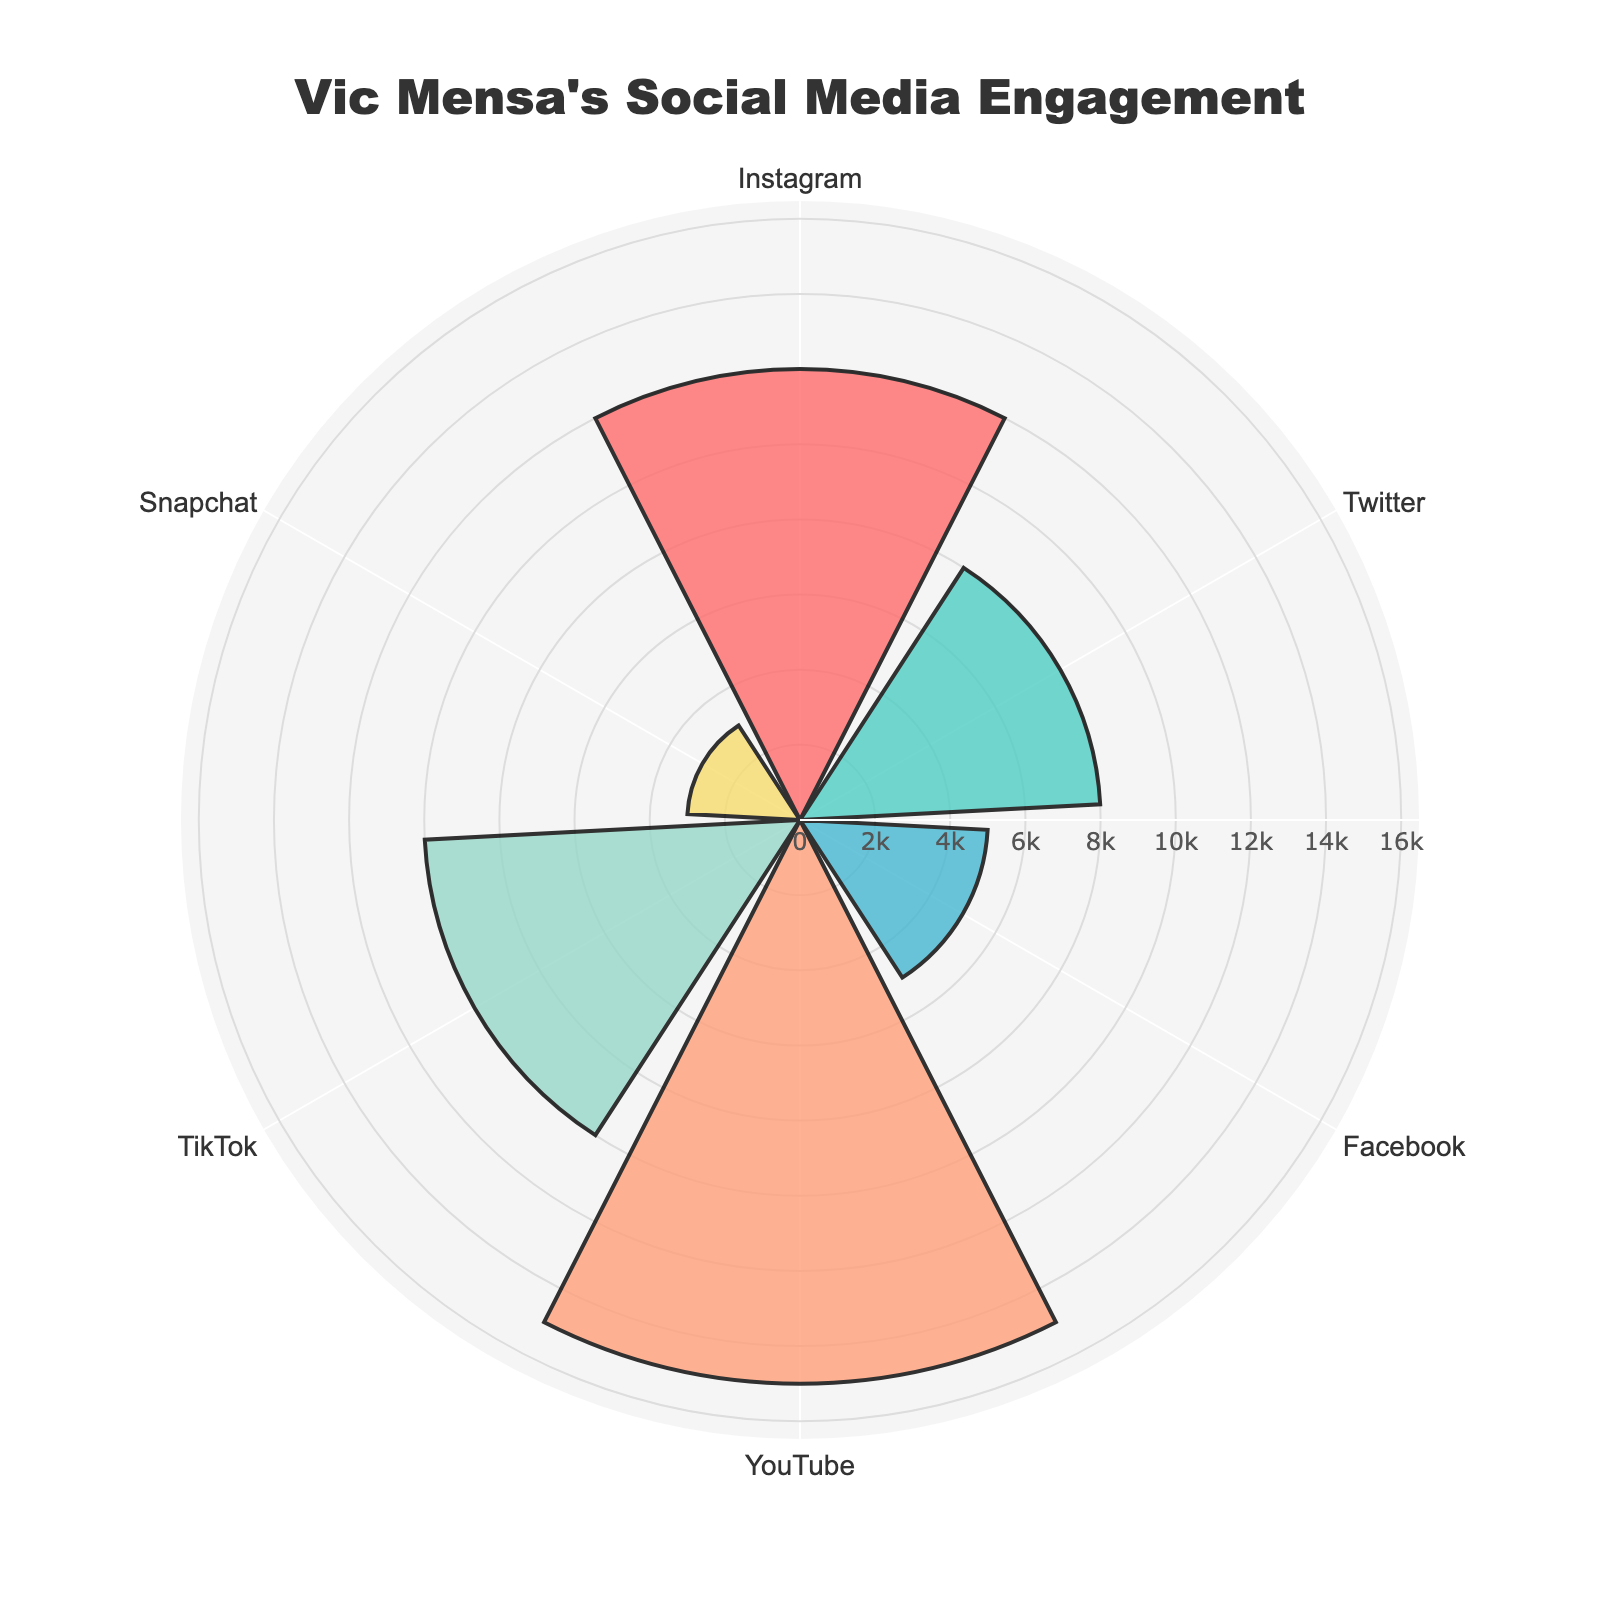Which platform has the highest social media engagement on Vic Mensa's posts? By looking at the chart, we can see the length of the bars representing engagement across different platforms. The longest bar corresponds to YouTube.
Answer: YouTube What are the two platforms with the lowest social media engagement on Vic Mensa's posts? Observing the chart, the shortest bars indicate the platforms with the lowest engagement. These platforms are Snapchat and Facebook.
Answer: Snapchat and Facebook What is the total social media engagement of Instagram and TikTok combined? To find the total engagement, sum the engagements of Instagram and TikTok, which are 12000 and 10000 respectively. Therefore, the total is 12000 + 10000.
Answer: 22000 How does Facebook's engagement compare to Snapchat's engagement? By comparing the bars for Facebook and Snapchat, we can see that Facebook's bar is longer than Snapchat's. This indicates that Facebook has higher engagement than Snapchat.
Answer: Facebook has higher engagement What's the radial range of the chart? The radial range can be observed from the polar chart's scale, which shows the range from 0 to the maximum engagement value extended by 10%. The maximum value is 15000, thus the range is approximately 0 to 16500.
Answer: 0 to 16500 Which platform's engagement is closest to 10000? Observing the chart, TikTok's engagement bar is closest to the 10000 mark.
Answer: TikTok What is the difference between Twitter's engagement and Facebook's engagement? Twitter has an engagement of 8000, while Facebook has 5000. The difference is calculated as 8000 - 5000.
Answer: 3000 What is the sum of the engagements across all platforms? To find the total engagement, add up all the values: 12000 (Instagram) + 8000 (Twitter) + 5000 (Facebook) + 15000 (YouTube) + 10000 (TikTok) + 3000 (Snapchat).
Answer: 53000 Does Instagram or Twitter have a higher engagement rate? By comparing the bars for Instagram and Twitter, Instagram's bar is longer. Thus, Instagram has higher engagement than Twitter.
Answer: Instagram has higher engagement Which platforms have engagement values in the range between 5000 and 10000? Looking at the chart, the platforms within that range are Twitter and TikTok.
Answer: Twitter and TikTok 